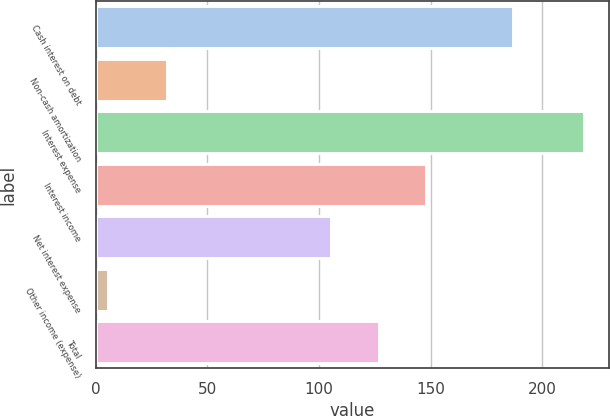Convert chart to OTSL. <chart><loc_0><loc_0><loc_500><loc_500><bar_chart><fcel>Cash interest on debt<fcel>Non-cash amortization<fcel>Interest expense<fcel>Interest income<fcel>Net interest expense<fcel>Other income (expense)<fcel>Total<nl><fcel>186.9<fcel>31.8<fcel>218.7<fcel>148.02<fcel>105.4<fcel>5.6<fcel>126.71<nl></chart> 